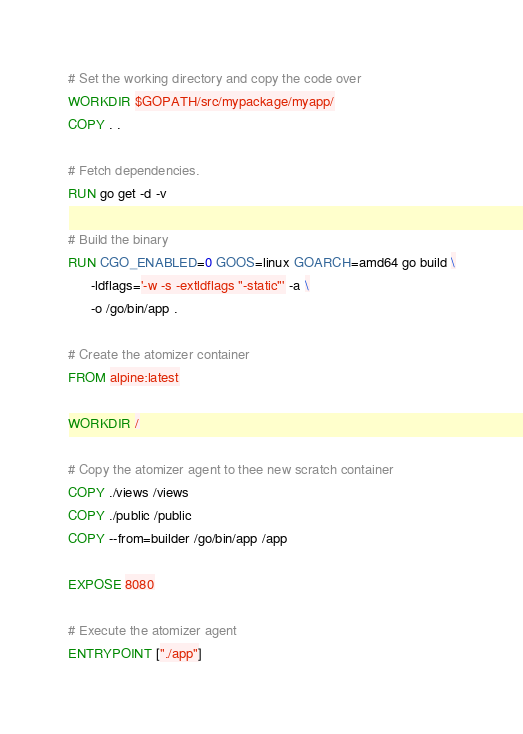Convert code to text. <code><loc_0><loc_0><loc_500><loc_500><_Dockerfile_># Set the working directory and copy the code over
WORKDIR $GOPATH/src/mypackage/myapp/
COPY . .

# Fetch dependencies.
RUN go get -d -v

# Build the binary
RUN CGO_ENABLED=0 GOOS=linux GOARCH=amd64 go build \
      -ldflags='-w -s -extldflags "-static"' -a \
      -o /go/bin/app .

# Create the atomizer container
FROM alpine:latest

WORKDIR /

# Copy the atomizer agent to thee new scratch container
COPY ./views /views
COPY ./public /public
COPY --from=builder /go/bin/app /app

EXPOSE 8080

# Execute the atomizer agent
ENTRYPOINT ["./app"]</code> 